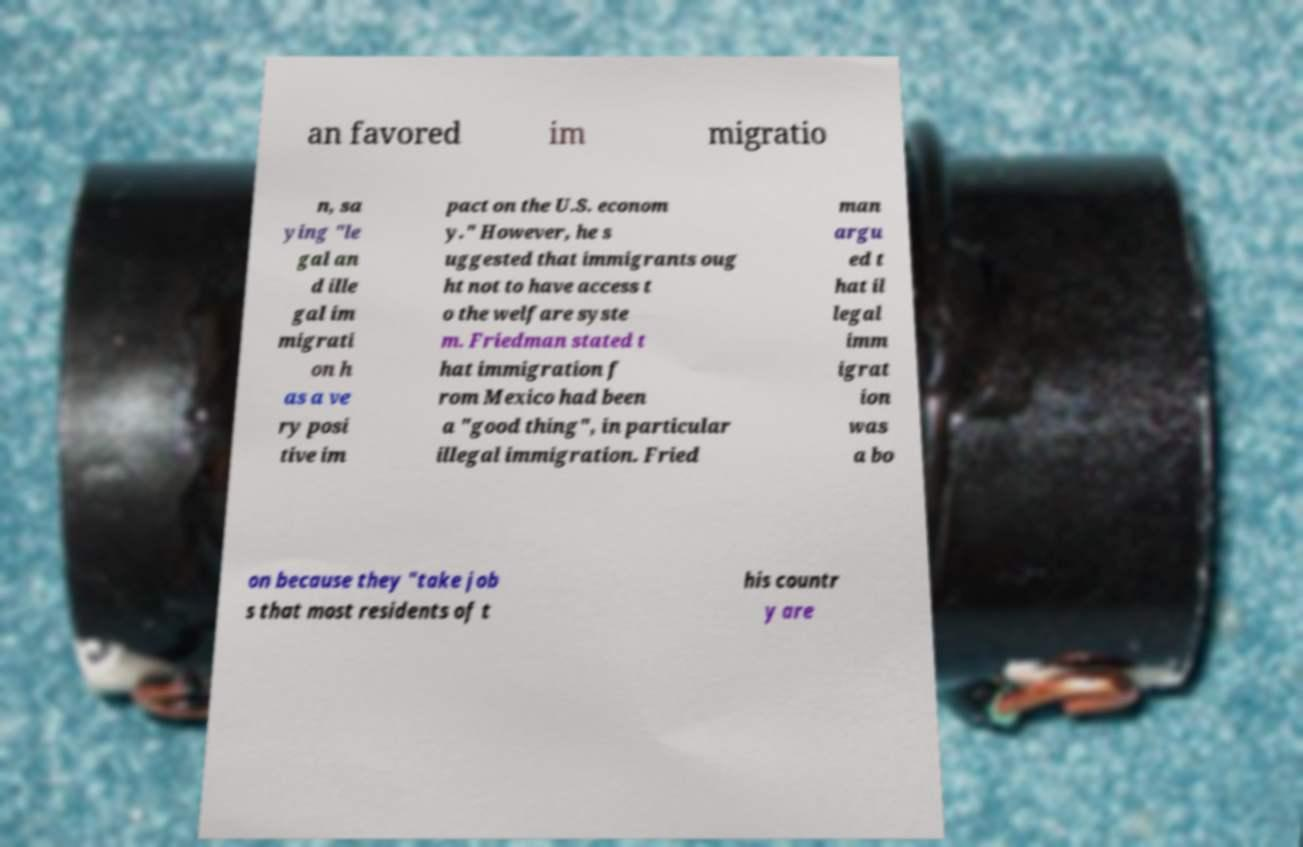What messages or text are displayed in this image? I need them in a readable, typed format. an favored im migratio n, sa ying "le gal an d ille gal im migrati on h as a ve ry posi tive im pact on the U.S. econom y." However, he s uggested that immigrants oug ht not to have access t o the welfare syste m. Friedman stated t hat immigration f rom Mexico had been a "good thing", in particular illegal immigration. Fried man argu ed t hat il legal imm igrat ion was a bo on because they "take job s that most residents of t his countr y are 